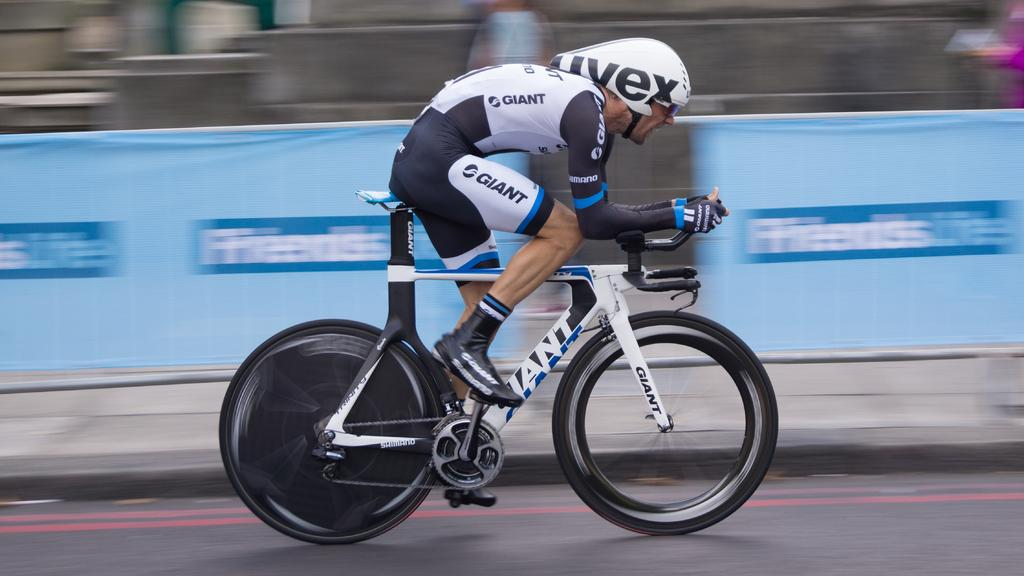Provide a one-sentence caption for the provided image. Man racing on a bike wearing Giant brand all over. 